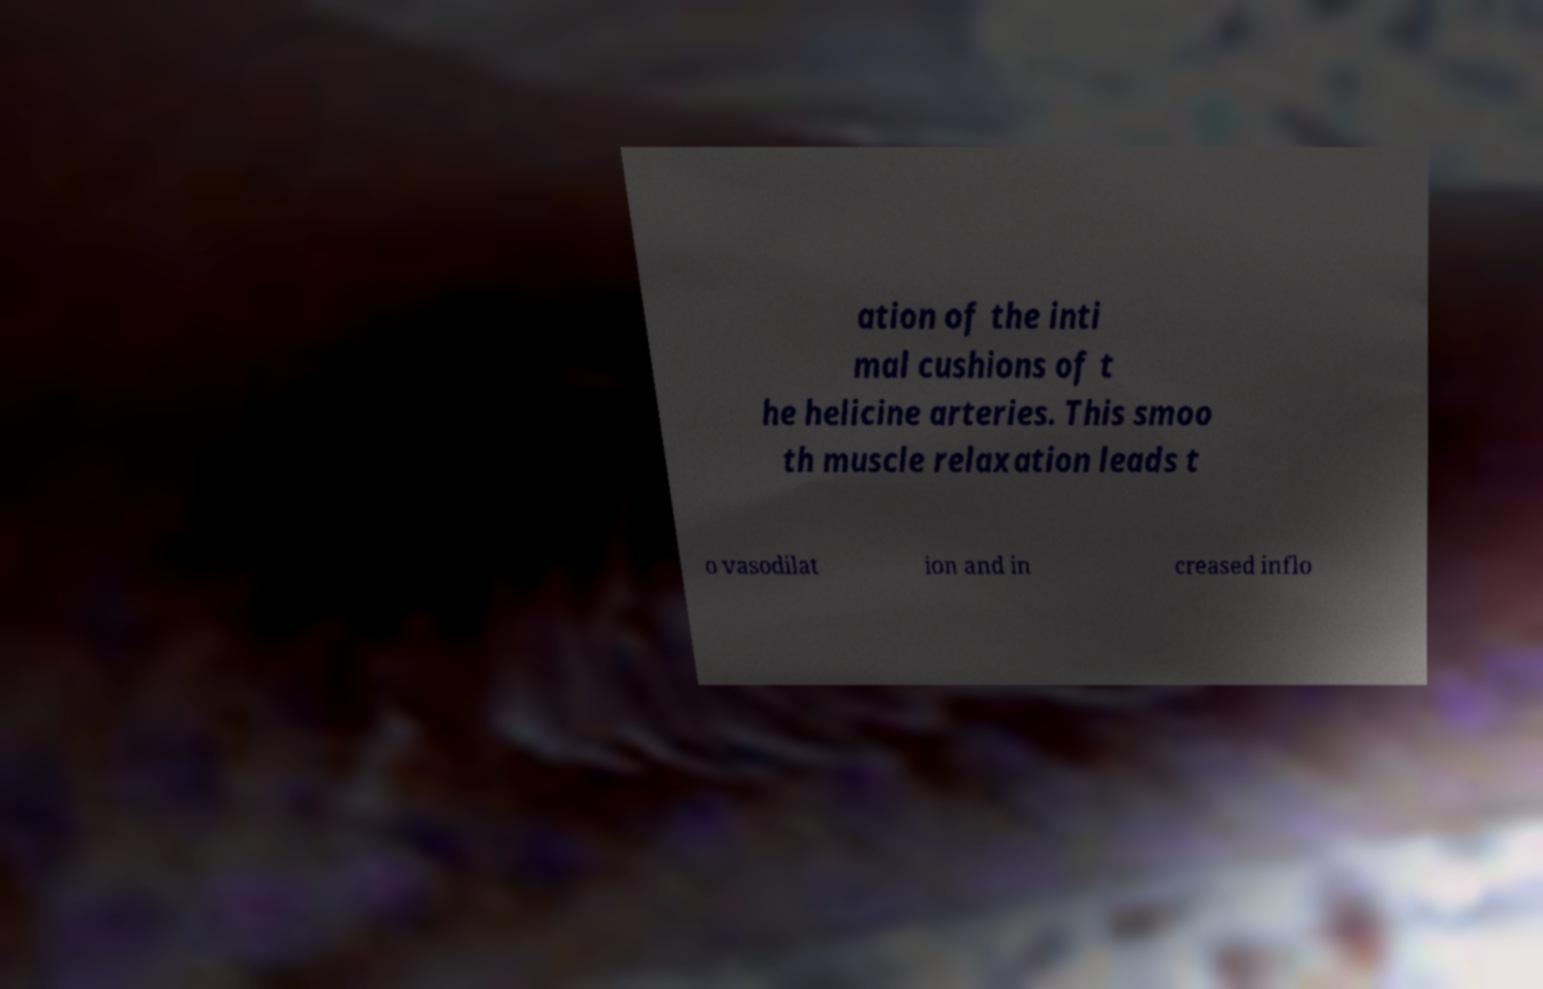Could you assist in decoding the text presented in this image and type it out clearly? ation of the inti mal cushions of t he helicine arteries. This smoo th muscle relaxation leads t o vasodilat ion and in creased inflo 